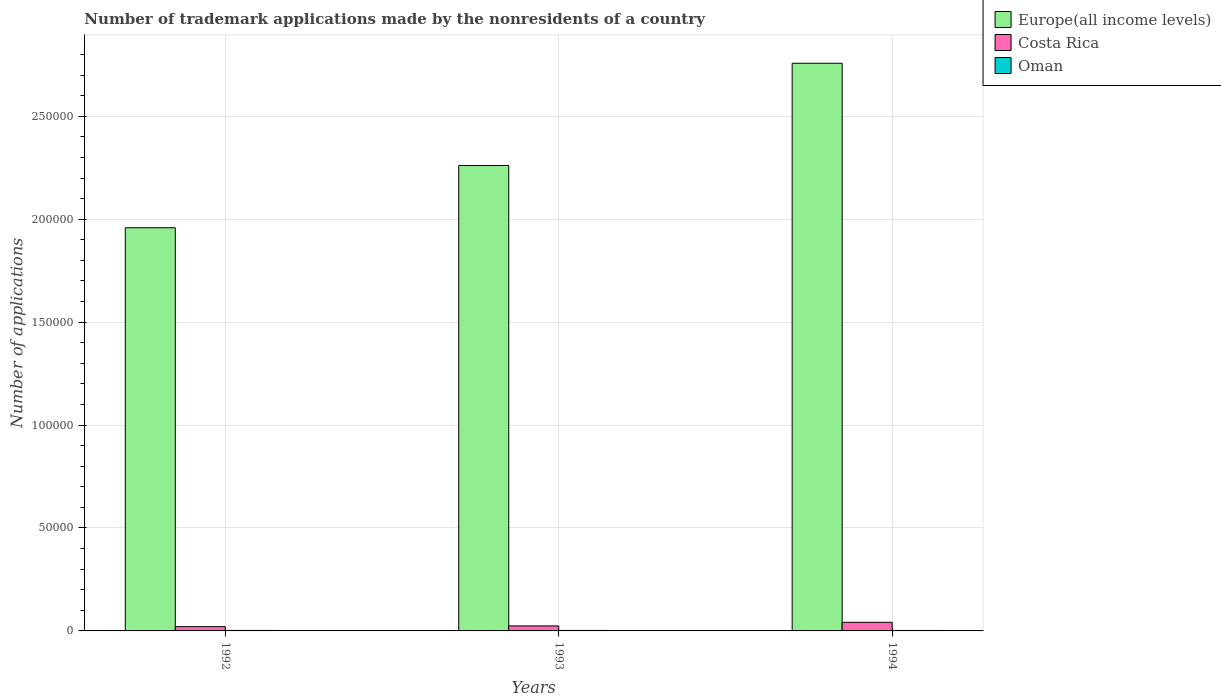How many groups of bars are there?
Ensure brevity in your answer.  3. Are the number of bars on each tick of the X-axis equal?
Give a very brief answer. Yes. How many bars are there on the 3rd tick from the right?
Your response must be concise. 3. What is the number of trademark applications made by the nonresidents in Oman in 1993?
Your response must be concise. 236. Across all years, what is the maximum number of trademark applications made by the nonresidents in Costa Rica?
Give a very brief answer. 4183. Across all years, what is the minimum number of trademark applications made by the nonresidents in Costa Rica?
Offer a very short reply. 2072. In which year was the number of trademark applications made by the nonresidents in Costa Rica maximum?
Keep it short and to the point. 1994. In which year was the number of trademark applications made by the nonresidents in Europe(all income levels) minimum?
Provide a succinct answer. 1992. What is the total number of trademark applications made by the nonresidents in Oman in the graph?
Provide a short and direct response. 697. What is the difference between the number of trademark applications made by the nonresidents in Costa Rica in 1992 and that in 1994?
Keep it short and to the point. -2111. What is the difference between the number of trademark applications made by the nonresidents in Costa Rica in 1993 and the number of trademark applications made by the nonresidents in Europe(all income levels) in 1994?
Your response must be concise. -2.73e+05. What is the average number of trademark applications made by the nonresidents in Costa Rica per year?
Make the answer very short. 2895. In the year 1994, what is the difference between the number of trademark applications made by the nonresidents in Oman and number of trademark applications made by the nonresidents in Costa Rica?
Give a very brief answer. -3963. In how many years, is the number of trademark applications made by the nonresidents in Costa Rica greater than 60000?
Keep it short and to the point. 0. What is the ratio of the number of trademark applications made by the nonresidents in Oman in 1993 to that in 1994?
Ensure brevity in your answer.  1.07. What is the difference between the highest and the second highest number of trademark applications made by the nonresidents in Europe(all income levels)?
Offer a very short reply. 4.97e+04. What is the difference between the highest and the lowest number of trademark applications made by the nonresidents in Costa Rica?
Make the answer very short. 2111. In how many years, is the number of trademark applications made by the nonresidents in Europe(all income levels) greater than the average number of trademark applications made by the nonresidents in Europe(all income levels) taken over all years?
Offer a very short reply. 1. What does the 3rd bar from the left in 1994 represents?
Keep it short and to the point. Oman. What does the 3rd bar from the right in 1993 represents?
Offer a very short reply. Europe(all income levels). Is it the case that in every year, the sum of the number of trademark applications made by the nonresidents in Europe(all income levels) and number of trademark applications made by the nonresidents in Oman is greater than the number of trademark applications made by the nonresidents in Costa Rica?
Provide a short and direct response. Yes. How many bars are there?
Ensure brevity in your answer.  9. Are all the bars in the graph horizontal?
Offer a terse response. No. How many years are there in the graph?
Offer a terse response. 3. What is the difference between two consecutive major ticks on the Y-axis?
Give a very brief answer. 5.00e+04. Where does the legend appear in the graph?
Your answer should be very brief. Top right. What is the title of the graph?
Offer a terse response. Number of trademark applications made by the nonresidents of a country. Does "Paraguay" appear as one of the legend labels in the graph?
Your answer should be very brief. No. What is the label or title of the Y-axis?
Keep it short and to the point. Number of applications. What is the Number of applications in Europe(all income levels) in 1992?
Provide a short and direct response. 1.96e+05. What is the Number of applications in Costa Rica in 1992?
Keep it short and to the point. 2072. What is the Number of applications in Oman in 1992?
Give a very brief answer. 241. What is the Number of applications in Europe(all income levels) in 1993?
Provide a short and direct response. 2.26e+05. What is the Number of applications of Costa Rica in 1993?
Your response must be concise. 2430. What is the Number of applications of Oman in 1993?
Ensure brevity in your answer.  236. What is the Number of applications of Europe(all income levels) in 1994?
Provide a short and direct response. 2.76e+05. What is the Number of applications in Costa Rica in 1994?
Provide a succinct answer. 4183. What is the Number of applications of Oman in 1994?
Make the answer very short. 220. Across all years, what is the maximum Number of applications in Europe(all income levels)?
Offer a terse response. 2.76e+05. Across all years, what is the maximum Number of applications of Costa Rica?
Ensure brevity in your answer.  4183. Across all years, what is the maximum Number of applications in Oman?
Provide a succinct answer. 241. Across all years, what is the minimum Number of applications of Europe(all income levels)?
Give a very brief answer. 1.96e+05. Across all years, what is the minimum Number of applications in Costa Rica?
Offer a terse response. 2072. Across all years, what is the minimum Number of applications of Oman?
Provide a short and direct response. 220. What is the total Number of applications in Europe(all income levels) in the graph?
Your answer should be very brief. 6.98e+05. What is the total Number of applications in Costa Rica in the graph?
Your answer should be very brief. 8685. What is the total Number of applications in Oman in the graph?
Your response must be concise. 697. What is the difference between the Number of applications of Europe(all income levels) in 1992 and that in 1993?
Ensure brevity in your answer.  -3.02e+04. What is the difference between the Number of applications of Costa Rica in 1992 and that in 1993?
Provide a succinct answer. -358. What is the difference between the Number of applications of Oman in 1992 and that in 1993?
Your answer should be very brief. 5. What is the difference between the Number of applications of Europe(all income levels) in 1992 and that in 1994?
Offer a terse response. -7.99e+04. What is the difference between the Number of applications of Costa Rica in 1992 and that in 1994?
Provide a succinct answer. -2111. What is the difference between the Number of applications of Europe(all income levels) in 1993 and that in 1994?
Keep it short and to the point. -4.97e+04. What is the difference between the Number of applications of Costa Rica in 1993 and that in 1994?
Keep it short and to the point. -1753. What is the difference between the Number of applications in Oman in 1993 and that in 1994?
Make the answer very short. 16. What is the difference between the Number of applications in Europe(all income levels) in 1992 and the Number of applications in Costa Rica in 1993?
Offer a very short reply. 1.93e+05. What is the difference between the Number of applications in Europe(all income levels) in 1992 and the Number of applications in Oman in 1993?
Provide a succinct answer. 1.96e+05. What is the difference between the Number of applications in Costa Rica in 1992 and the Number of applications in Oman in 1993?
Make the answer very short. 1836. What is the difference between the Number of applications of Europe(all income levels) in 1992 and the Number of applications of Costa Rica in 1994?
Keep it short and to the point. 1.92e+05. What is the difference between the Number of applications of Europe(all income levels) in 1992 and the Number of applications of Oman in 1994?
Give a very brief answer. 1.96e+05. What is the difference between the Number of applications of Costa Rica in 1992 and the Number of applications of Oman in 1994?
Give a very brief answer. 1852. What is the difference between the Number of applications of Europe(all income levels) in 1993 and the Number of applications of Costa Rica in 1994?
Your answer should be very brief. 2.22e+05. What is the difference between the Number of applications of Europe(all income levels) in 1993 and the Number of applications of Oman in 1994?
Your answer should be very brief. 2.26e+05. What is the difference between the Number of applications of Costa Rica in 1993 and the Number of applications of Oman in 1994?
Your response must be concise. 2210. What is the average Number of applications in Europe(all income levels) per year?
Ensure brevity in your answer.  2.33e+05. What is the average Number of applications in Costa Rica per year?
Provide a succinct answer. 2895. What is the average Number of applications of Oman per year?
Make the answer very short. 232.33. In the year 1992, what is the difference between the Number of applications of Europe(all income levels) and Number of applications of Costa Rica?
Give a very brief answer. 1.94e+05. In the year 1992, what is the difference between the Number of applications of Europe(all income levels) and Number of applications of Oman?
Provide a short and direct response. 1.96e+05. In the year 1992, what is the difference between the Number of applications in Costa Rica and Number of applications in Oman?
Your answer should be compact. 1831. In the year 1993, what is the difference between the Number of applications in Europe(all income levels) and Number of applications in Costa Rica?
Make the answer very short. 2.24e+05. In the year 1993, what is the difference between the Number of applications in Europe(all income levels) and Number of applications in Oman?
Offer a very short reply. 2.26e+05. In the year 1993, what is the difference between the Number of applications in Costa Rica and Number of applications in Oman?
Ensure brevity in your answer.  2194. In the year 1994, what is the difference between the Number of applications of Europe(all income levels) and Number of applications of Costa Rica?
Offer a very short reply. 2.72e+05. In the year 1994, what is the difference between the Number of applications in Europe(all income levels) and Number of applications in Oman?
Ensure brevity in your answer.  2.76e+05. In the year 1994, what is the difference between the Number of applications of Costa Rica and Number of applications of Oman?
Offer a terse response. 3963. What is the ratio of the Number of applications in Europe(all income levels) in 1992 to that in 1993?
Ensure brevity in your answer.  0.87. What is the ratio of the Number of applications in Costa Rica in 1992 to that in 1993?
Make the answer very short. 0.85. What is the ratio of the Number of applications of Oman in 1992 to that in 1993?
Your response must be concise. 1.02. What is the ratio of the Number of applications in Europe(all income levels) in 1992 to that in 1994?
Offer a terse response. 0.71. What is the ratio of the Number of applications in Costa Rica in 1992 to that in 1994?
Ensure brevity in your answer.  0.5. What is the ratio of the Number of applications in Oman in 1992 to that in 1994?
Your response must be concise. 1.1. What is the ratio of the Number of applications of Europe(all income levels) in 1993 to that in 1994?
Make the answer very short. 0.82. What is the ratio of the Number of applications in Costa Rica in 1993 to that in 1994?
Your answer should be very brief. 0.58. What is the ratio of the Number of applications of Oman in 1993 to that in 1994?
Make the answer very short. 1.07. What is the difference between the highest and the second highest Number of applications of Europe(all income levels)?
Give a very brief answer. 4.97e+04. What is the difference between the highest and the second highest Number of applications in Costa Rica?
Offer a very short reply. 1753. What is the difference between the highest and the lowest Number of applications of Europe(all income levels)?
Make the answer very short. 7.99e+04. What is the difference between the highest and the lowest Number of applications in Costa Rica?
Make the answer very short. 2111. What is the difference between the highest and the lowest Number of applications of Oman?
Ensure brevity in your answer.  21. 